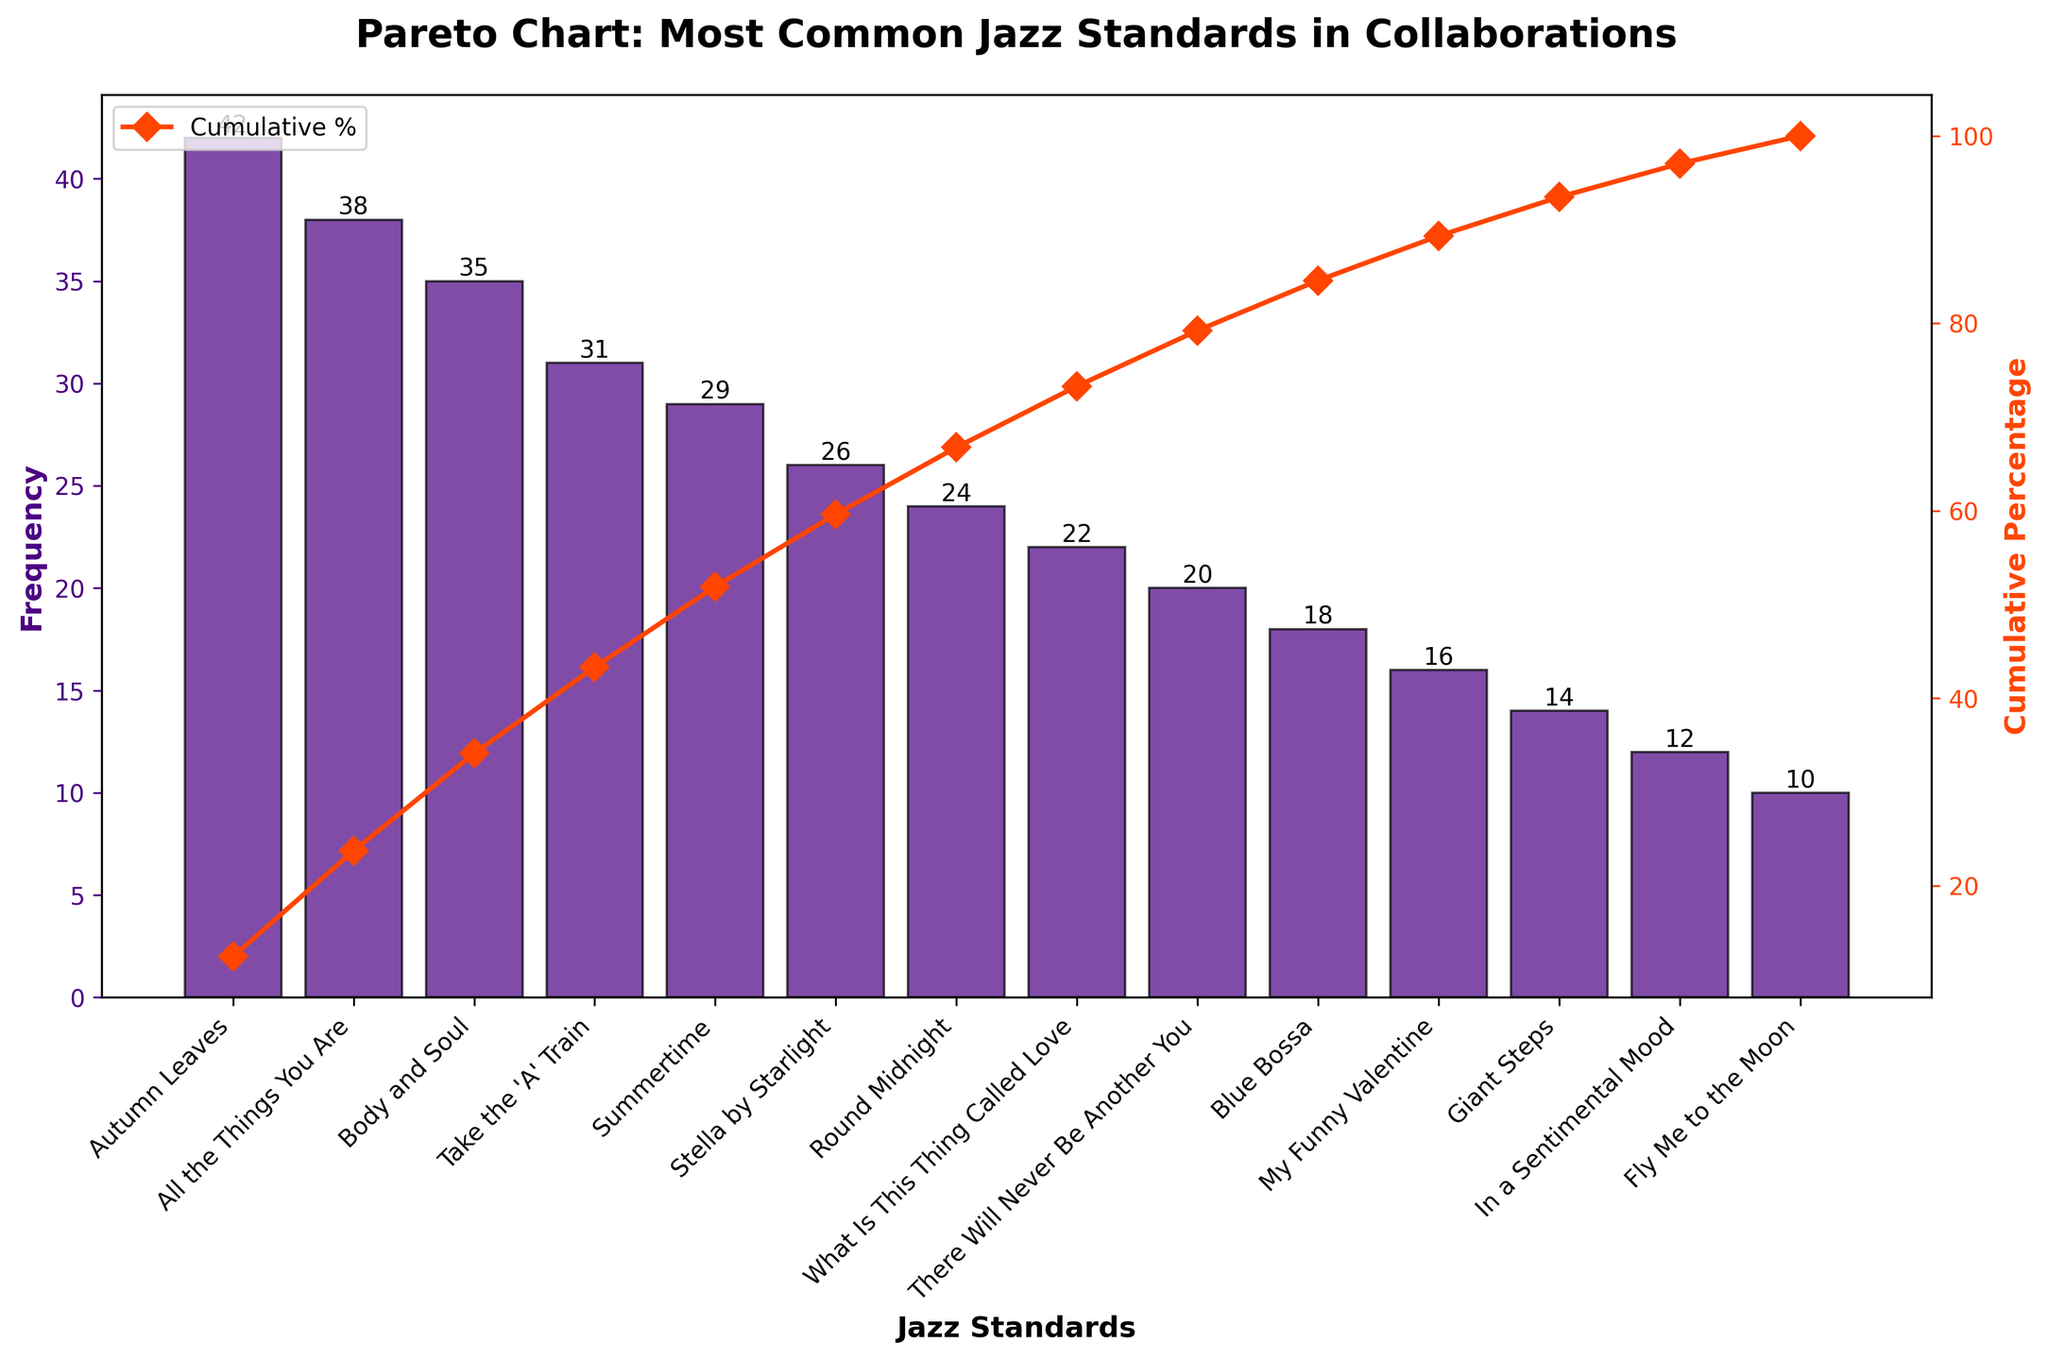What is the title of the chart? The title is usually displayed at the top of the figure in a larger and bold font to grab attention. Here, it says, "Pareto Chart: Most Common Jazz Standards in Collaborations".
Answer: Pareto Chart: Most Common Jazz Standards in Collaborations How many jazz standards are displayed in the chart? Count the number of bars or categories on the x-axis. Each bar represents a unique jazz standard.
Answer: 14 Which jazz standard has the highest frequency of occurrence? Look for the tallest bar on the chart and its associated label. The tallest bar represents the highest frequency.
Answer: Autumn Leaves What is the frequency of "Take the 'A' Train"? Find the bar labeled "Take the 'A' Train" and check the height of the bar or the value label on top of it.
Answer: 31 What percentage does "Autumn Leaves" contribute to the cumulative percentage? Locate "Autumn Leaves" on the x-axis and refer to the corresponding cumulative percentage line at the same point, which is marked by the orange line graph.
Answer: About 12.72% What is the cumulative percentage when you reach "Stella by Starlight"? Follow the cumulative percentage line (orange) to "Stella by Starlight" and read the corresponding percentage value.
Answer: About 80.56% Which jazz standard has the lowest frequency of occurrence? Look for the shortest bar on the chart and its associated label. The shortest bar represents the lowest frequency.
Answer: Fly Me to the Moon How many jazz standards have a frequency greater than 30? Identify and count the bars in the chart that have a height greater than 30. The height of each bar corresponds to its frequency.
Answer: 4 What is the sum of frequencies of "Summertime" and "Stella by Starlight"? Find the frequency values for both "Summertime" (29) and "Stella by Starlight" (26), and then add them together: 29 + 26.
Answer: 55 What is the difference in frequency between "All the Things You Are" and "Body and Soul"? Look at the frequencies for "All the Things You Are" (38) and "Body and Soul" (35), and then subtract the smaller value from the larger value: 38 - 35.
Answer: 3 